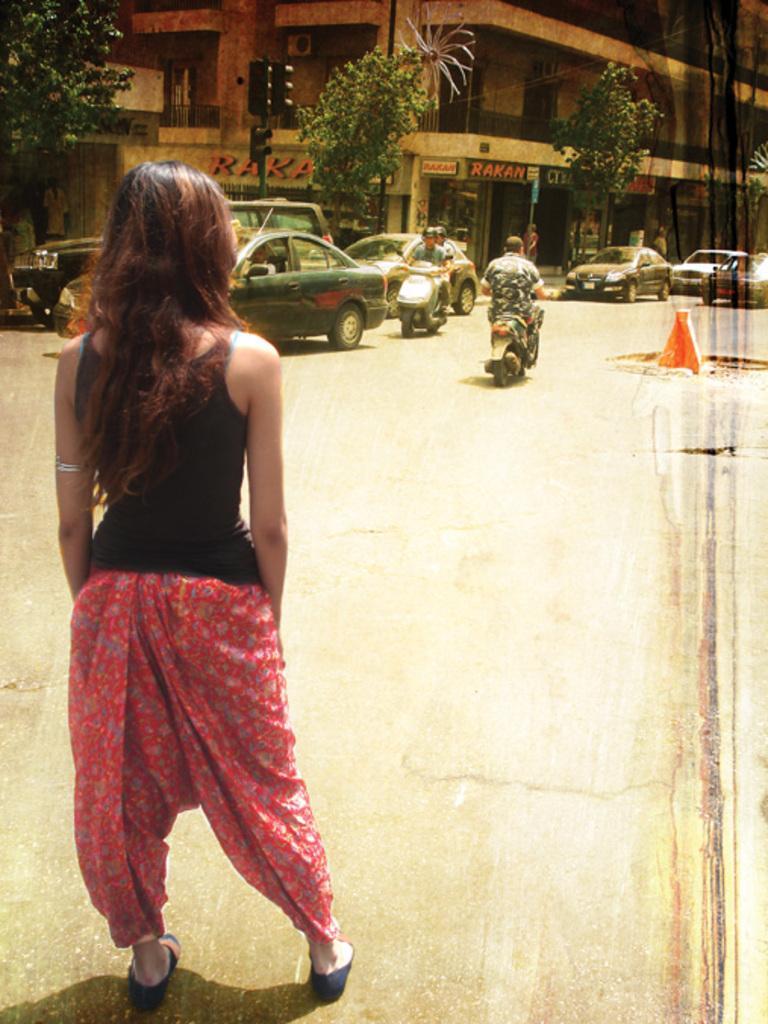Please provide a concise description of this image. This picture shows few cars and couple of motorcycles moving on the road and we see a woman standing and we see few trees and a building and we see a cone on the road. 